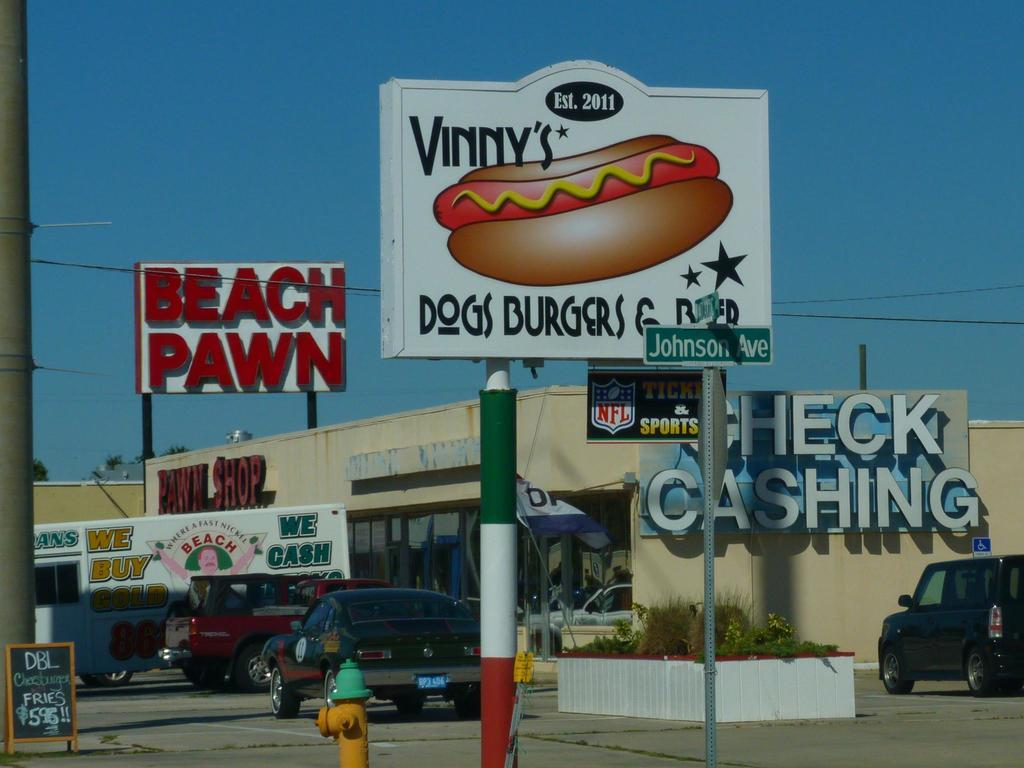<image>
Summarize the visual content of the image. The pawn shop next to the the ad for Vinny's dogs. 